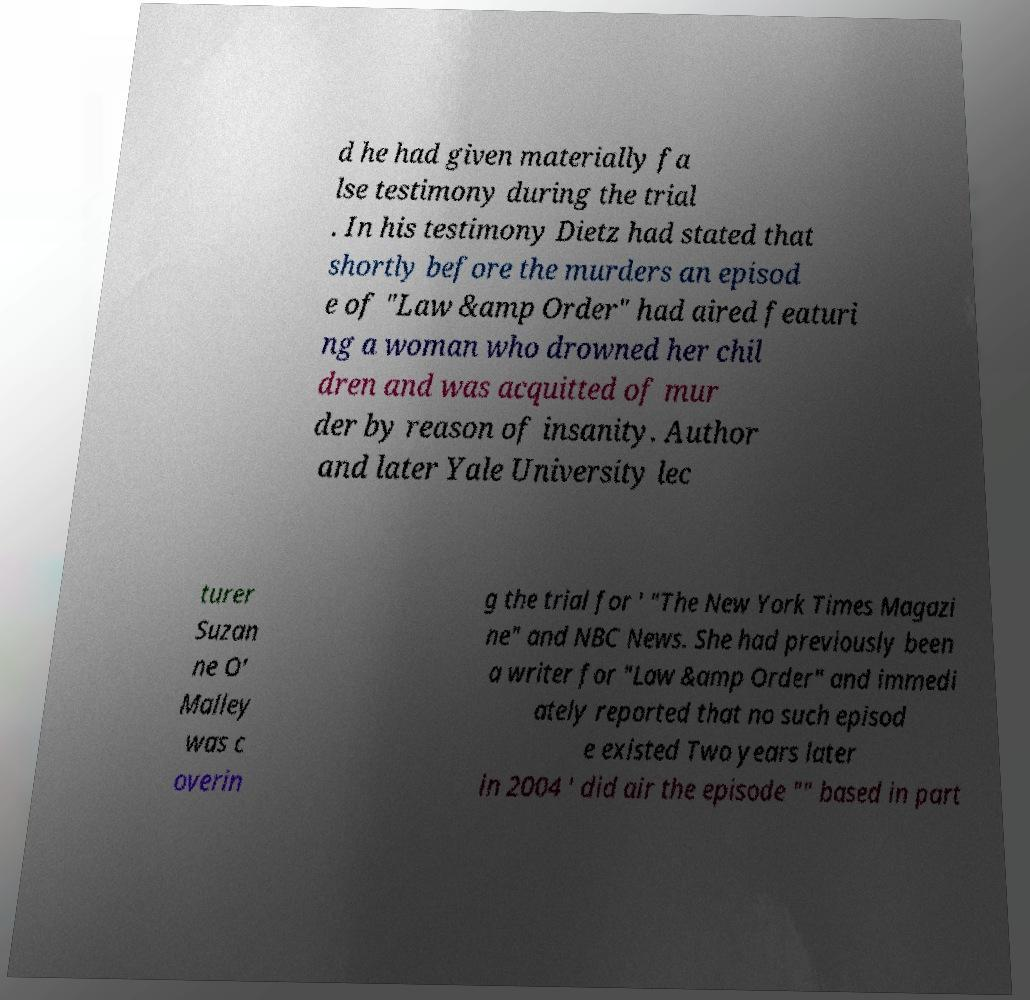Please identify and transcribe the text found in this image. d he had given materially fa lse testimony during the trial . In his testimony Dietz had stated that shortly before the murders an episod e of "Law &amp Order" had aired featuri ng a woman who drowned her chil dren and was acquitted of mur der by reason of insanity. Author and later Yale University lec turer Suzan ne O' Malley was c overin g the trial for ' "The New York Times Magazi ne" and NBC News. She had previously been a writer for "Law &amp Order" and immedi ately reported that no such episod e existed Two years later in 2004 ' did air the episode "" based in part 